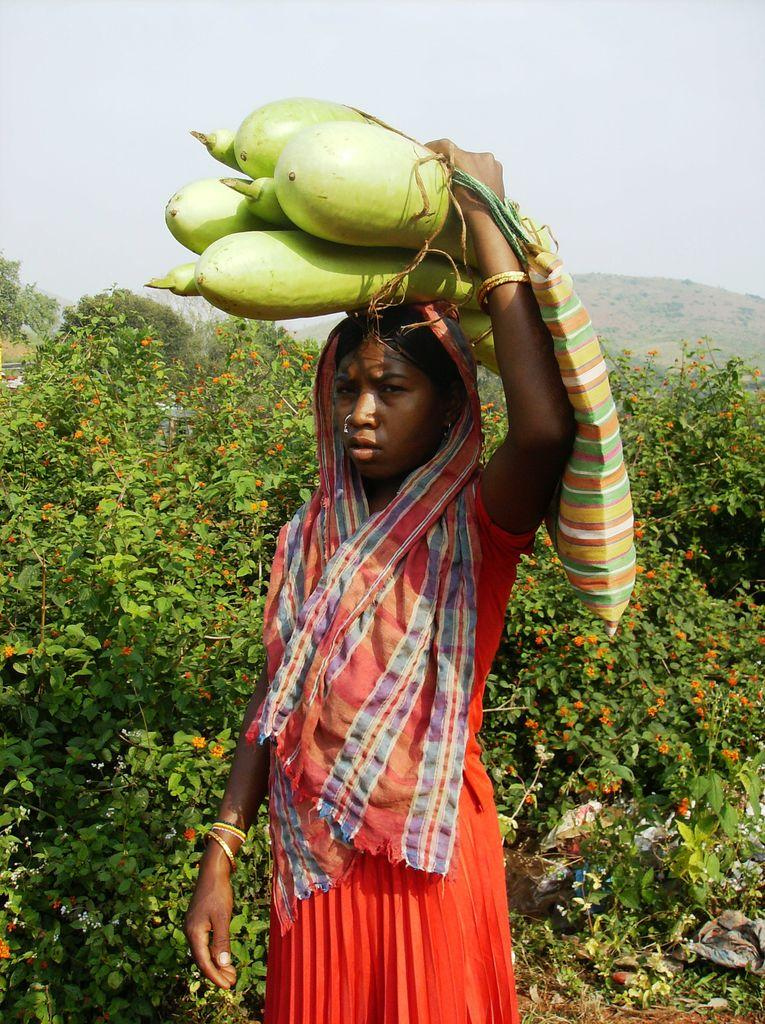What is the nationality of the girl in the picture? The girl in the picture is Indian. What color is the dress the girl is wearing? The girl is wearing an orange dress. Where is the girl positioned in the image? The girl is standing in the front. What is the girl holding on her head? The girl is holding a bottle gourd on her head. What can be seen in the background of the image? There are plants visible in the background of the image. What type of payment method is the girl using in the image? There is no payment method present in the image; the girl is holding a bottle gourd on her head. What role does the calculator play in the image? There is no calculator present in the image. 